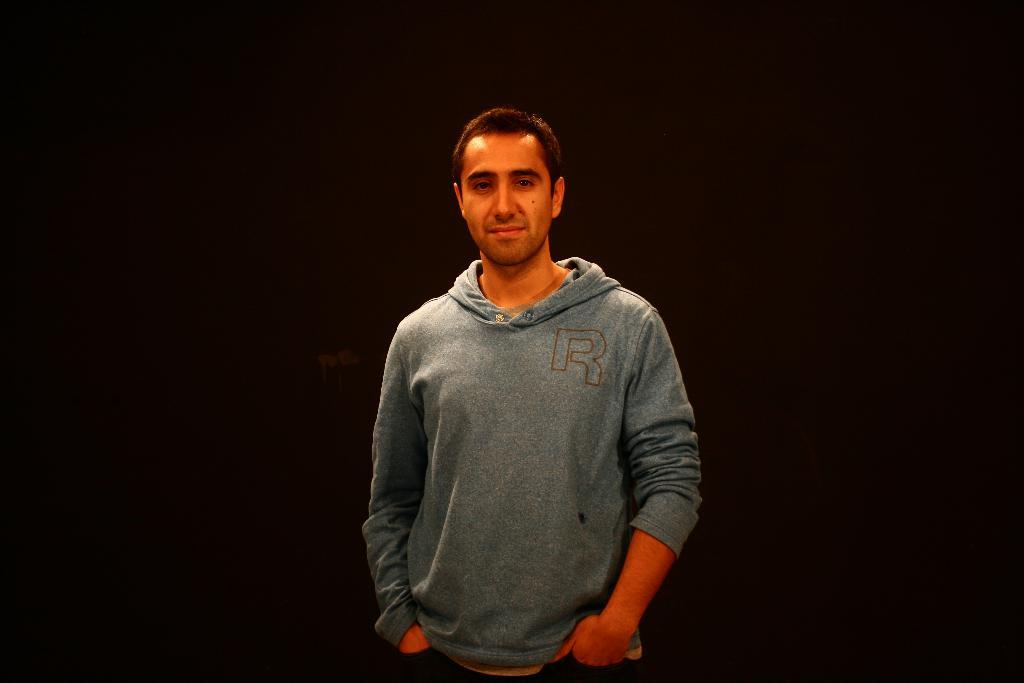What is the main subject of the image? There is a person standing in the image. What is the person wearing? The person is wearing a grey color hoodie. What is the person's facial expression? The person is smiling. What can be observed about the background of the image? The background of the image is completely dark. Is there a woman working on a farm in the background of the image? There is no woman or farm present in the image; it features a person standing in a dark background. Can you see the person's grandfather in the image? There is no mention of a grandfather in the image, and no other person is visible besides the one standing. 